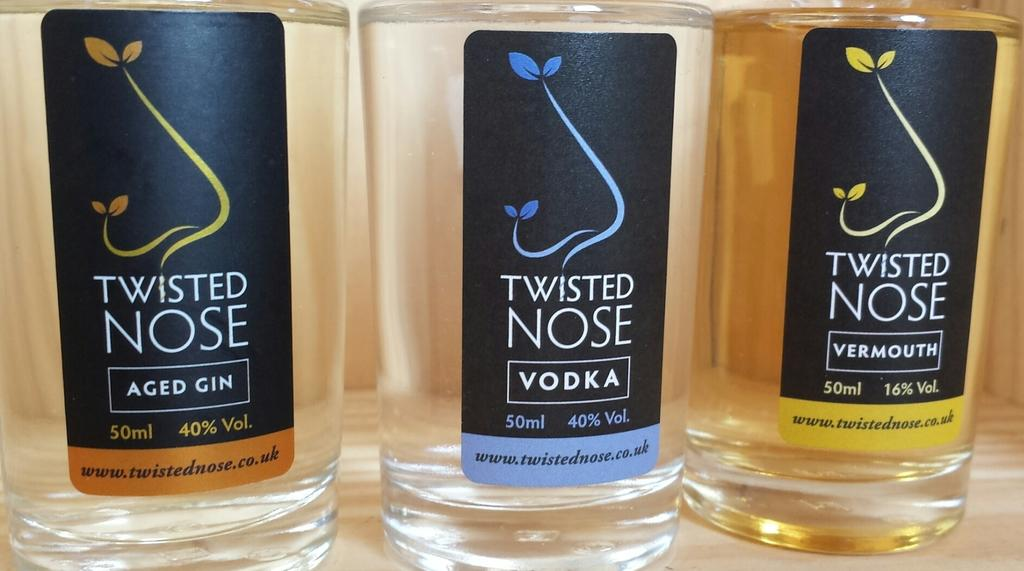<image>
Render a clear and concise summary of the photo. Two bottles of Twisted Nose aged gin, vodka and vermouth on the counter. 